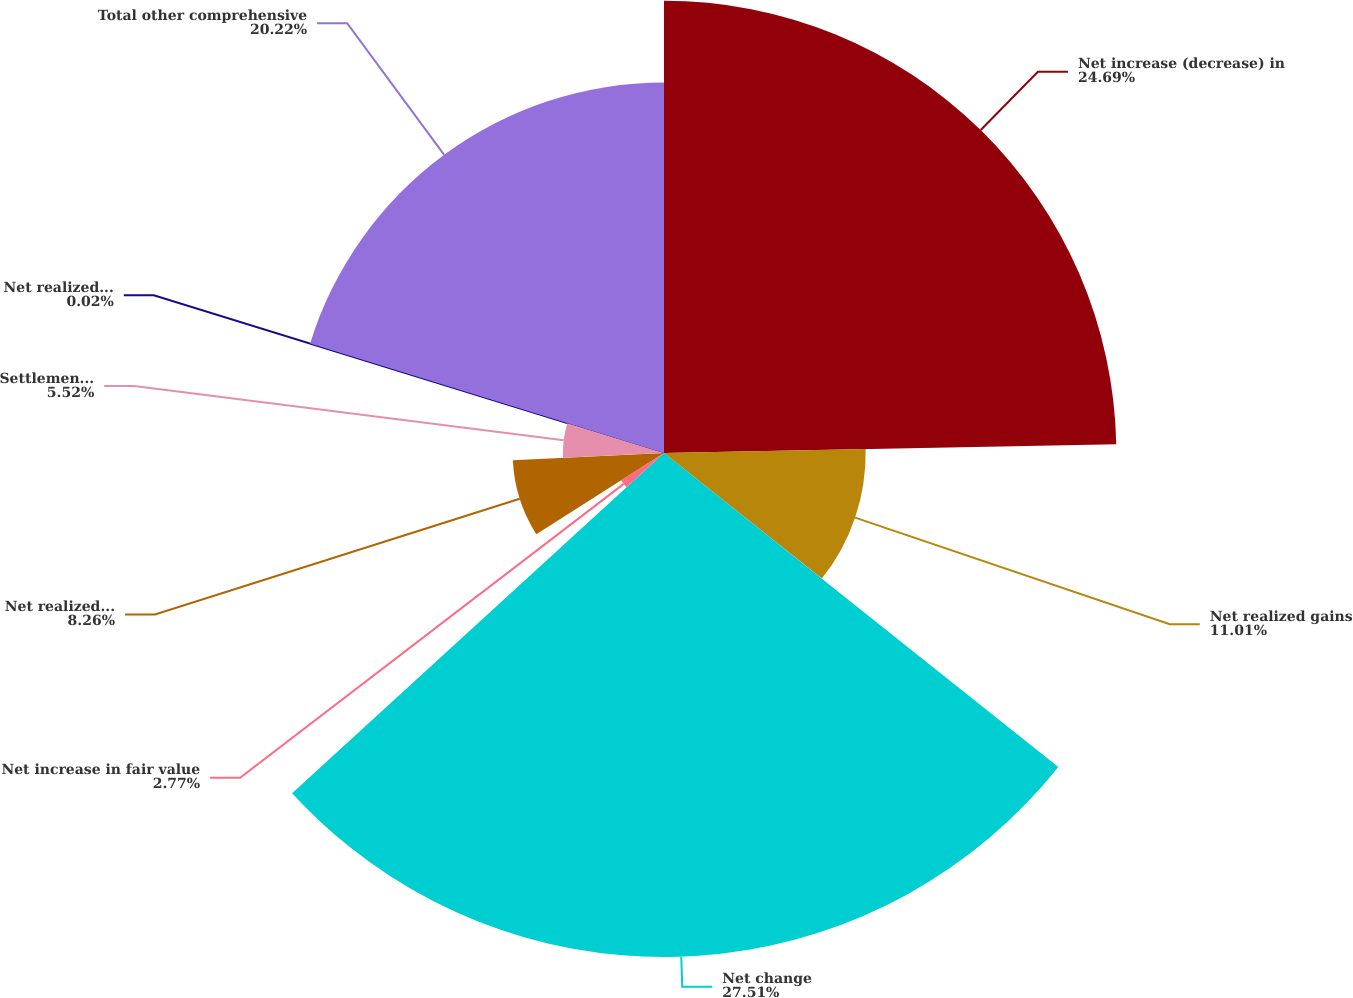Convert chart. <chart><loc_0><loc_0><loc_500><loc_500><pie_chart><fcel>Net increase (decrease) in<fcel>Net realized gains<fcel>Net change<fcel>Net increase in fair value<fcel>Net realized losses<fcel>Settlements curtailments and<fcel>Net realized (gains) losses<fcel>Total other comprehensive<nl><fcel>24.69%<fcel>11.01%<fcel>27.51%<fcel>2.77%<fcel>8.26%<fcel>5.52%<fcel>0.02%<fcel>20.22%<nl></chart> 